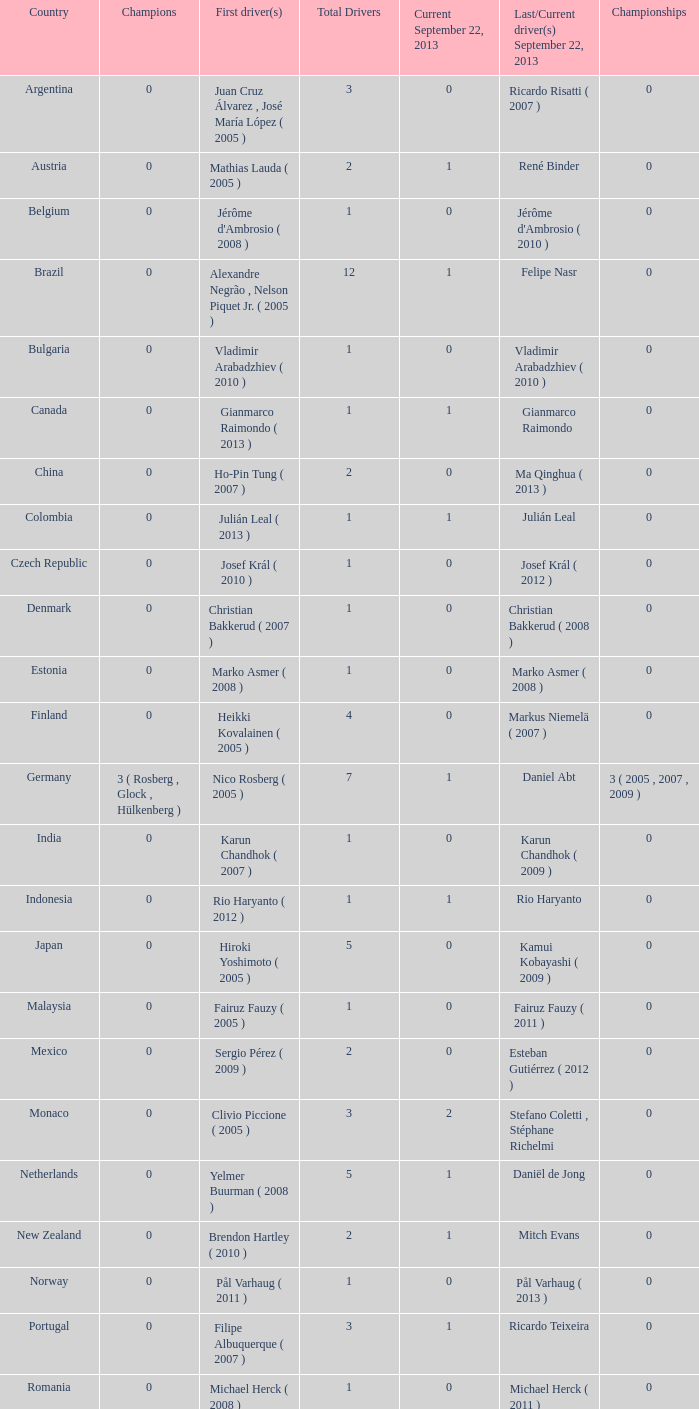How many champions were there when the first driver was hiroki yoshimoto ( 2005 )? 0.0. 